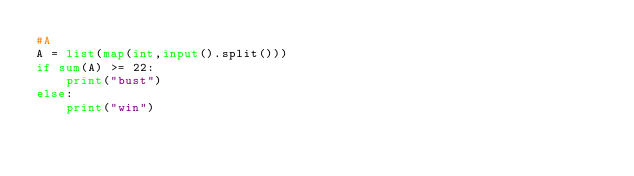Convert code to text. <code><loc_0><loc_0><loc_500><loc_500><_Python_>#A
A = list(map(int,input().split()))
if sum(A) >= 22:
    print("bust")
else:
    print("win")
</code> 